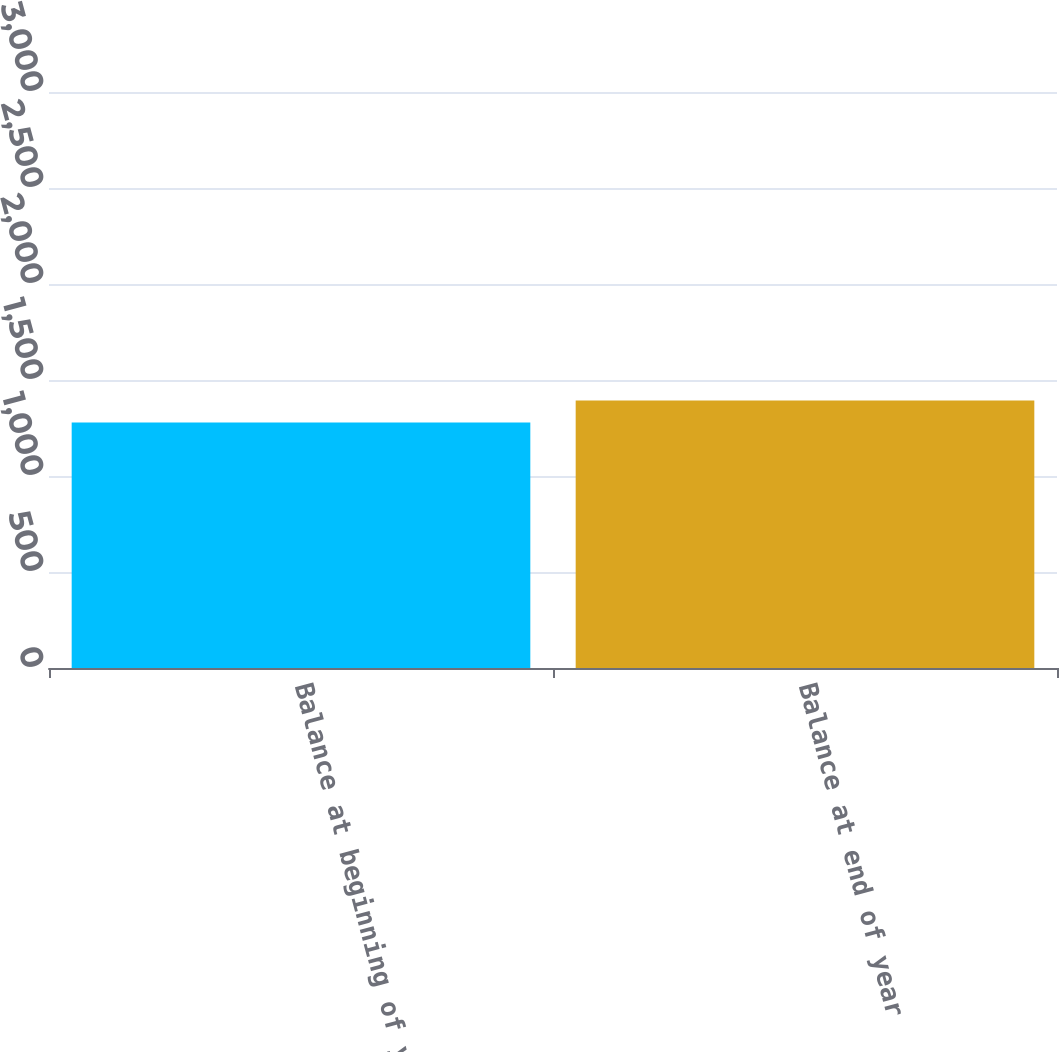<chart> <loc_0><loc_0><loc_500><loc_500><bar_chart><fcel>Balance at beginning of year<fcel>Balance at end of year<nl><fcel>2685<fcel>2924<nl></chart> 